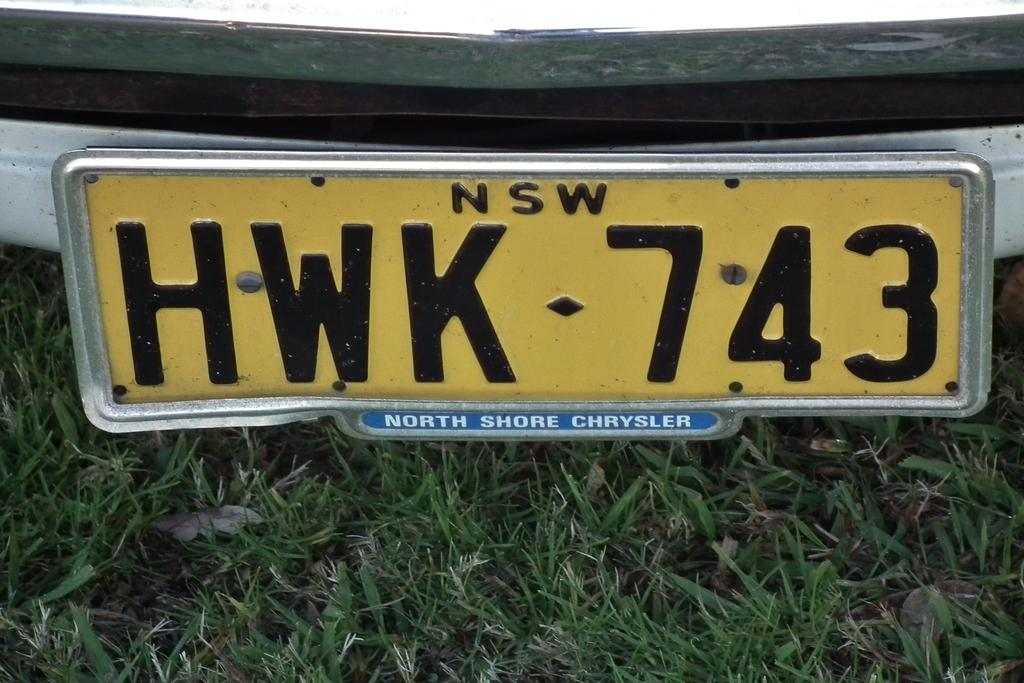<image>
Offer a succinct explanation of the picture presented. an image of car license plates for North Shore Chrysler 